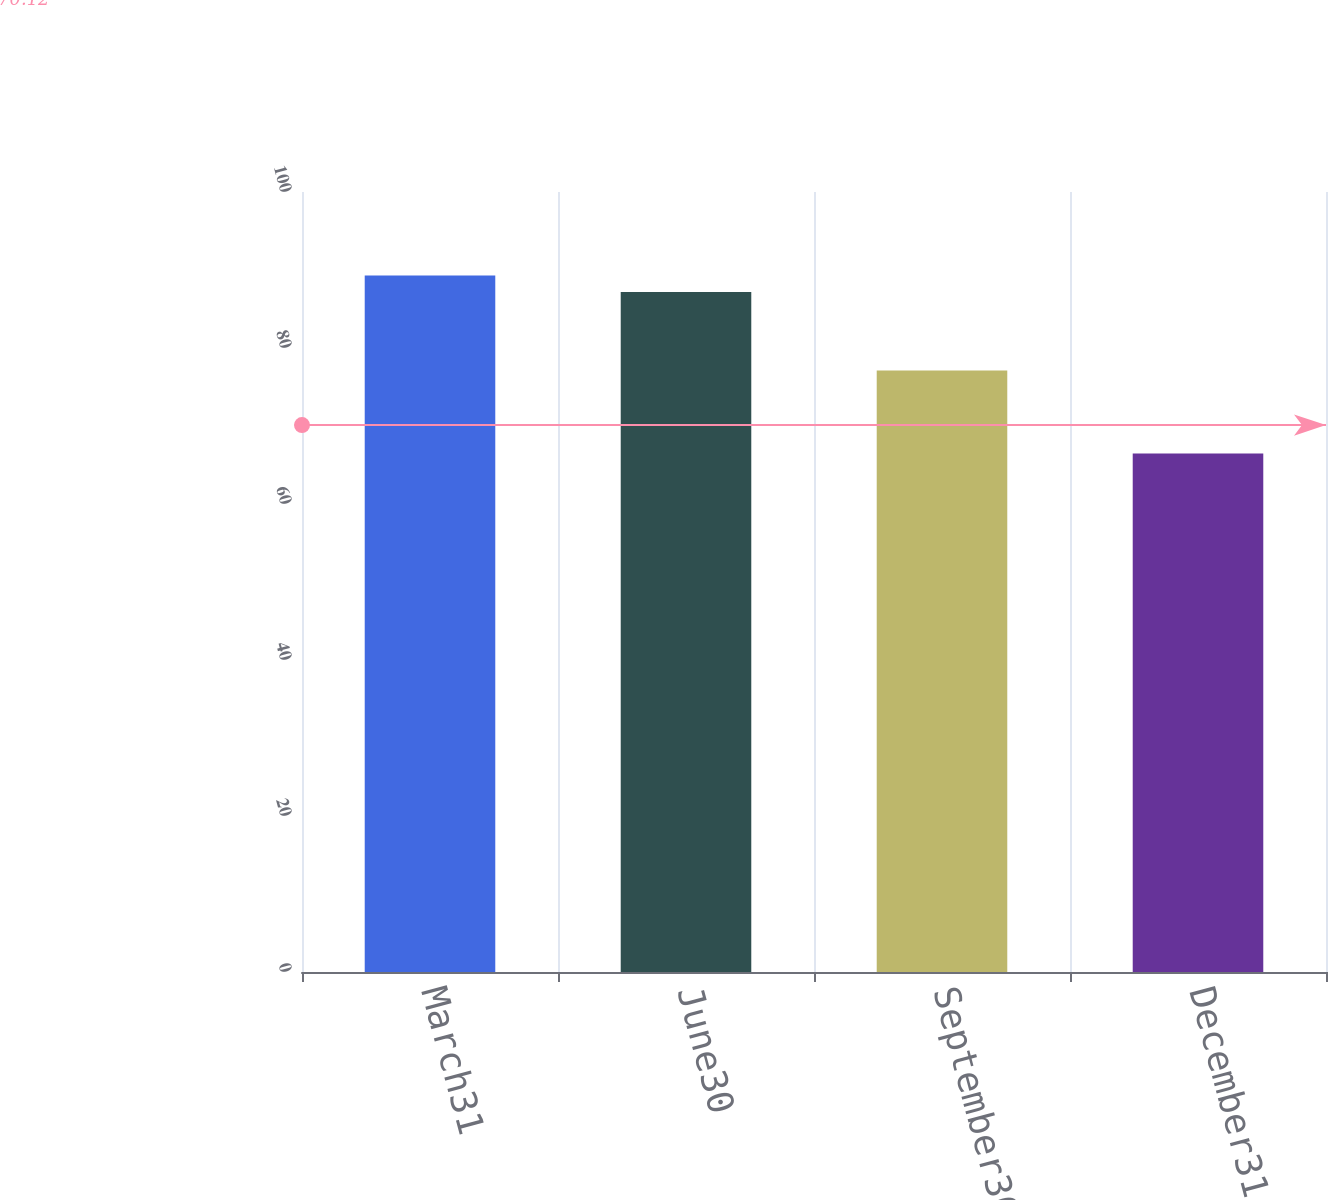Convert chart to OTSL. <chart><loc_0><loc_0><loc_500><loc_500><bar_chart><fcel>March31<fcel>June30<fcel>September30<fcel>December31<nl><fcel>89.28<fcel>87.19<fcel>77.12<fcel>66.49<nl></chart> 